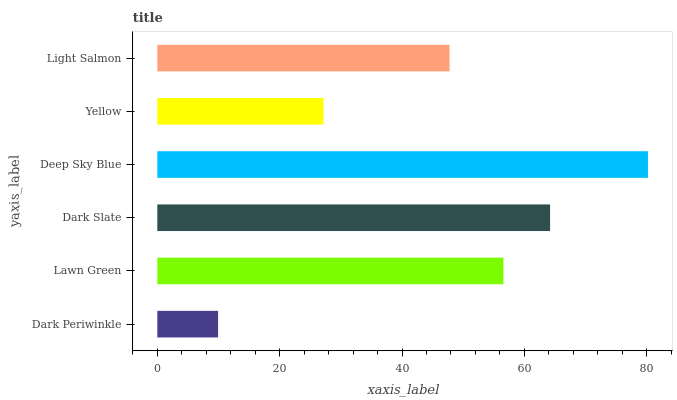Is Dark Periwinkle the minimum?
Answer yes or no. Yes. Is Deep Sky Blue the maximum?
Answer yes or no. Yes. Is Lawn Green the minimum?
Answer yes or no. No. Is Lawn Green the maximum?
Answer yes or no. No. Is Lawn Green greater than Dark Periwinkle?
Answer yes or no. Yes. Is Dark Periwinkle less than Lawn Green?
Answer yes or no. Yes. Is Dark Periwinkle greater than Lawn Green?
Answer yes or no. No. Is Lawn Green less than Dark Periwinkle?
Answer yes or no. No. Is Lawn Green the high median?
Answer yes or no. Yes. Is Light Salmon the low median?
Answer yes or no. Yes. Is Dark Periwinkle the high median?
Answer yes or no. No. Is Deep Sky Blue the low median?
Answer yes or no. No. 